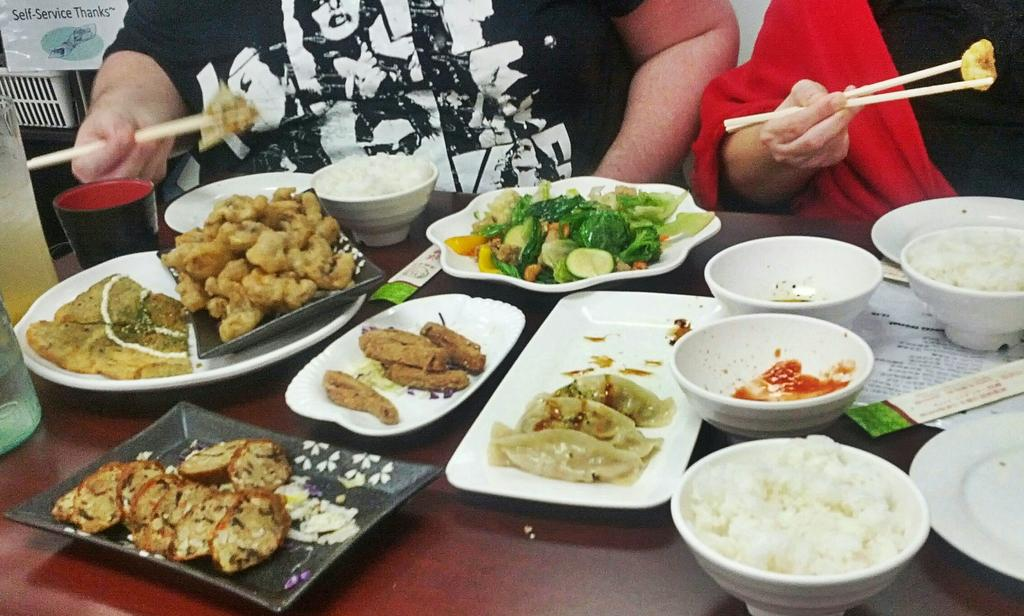How many people are in the image? There are two persons in the image. What are the persons holding in their hands? The persons are holding chopsticks. What can be seen on the table in the image? There is a food item, plates, bowls, trays, and a glass on the table. What type of food items are present on the table? There are food items on plates, bowls, and trays on the table. What type of army is visible in the image? There is no army present in the image. What kind of tree can be seen growing through the table in the image? There is no tree growing through the table in the image. 